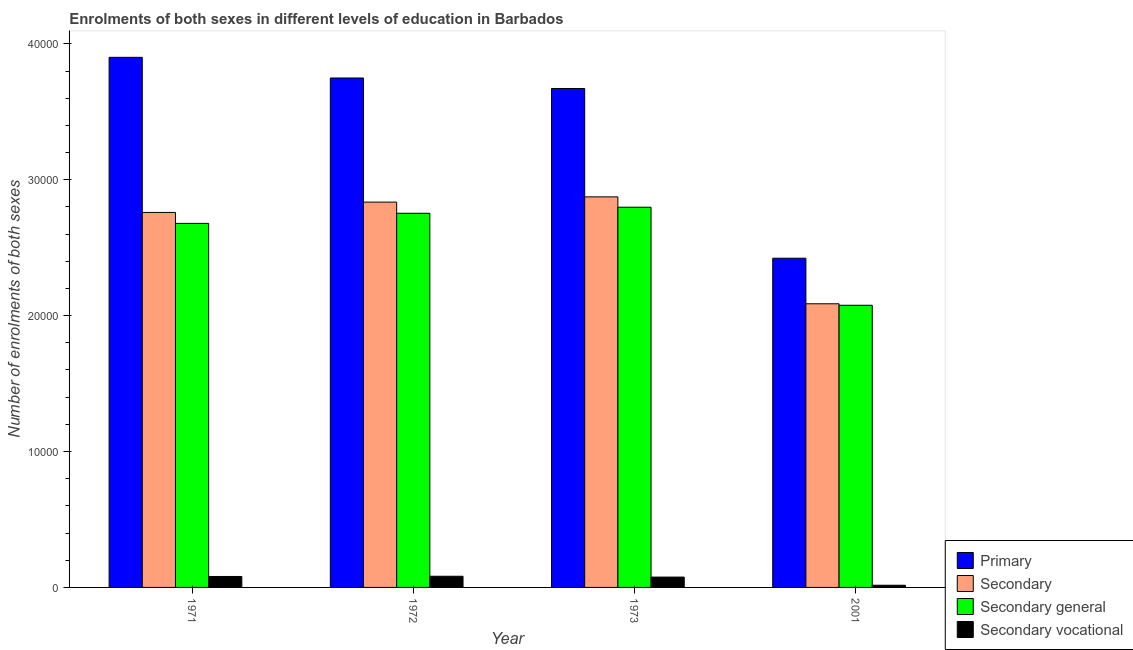How many bars are there on the 4th tick from the right?
Give a very brief answer. 4. What is the label of the 2nd group of bars from the left?
Ensure brevity in your answer.  1972. What is the number of enrolments in secondary education in 1971?
Your response must be concise. 2.76e+04. Across all years, what is the maximum number of enrolments in primary education?
Make the answer very short. 3.90e+04. Across all years, what is the minimum number of enrolments in secondary general education?
Ensure brevity in your answer.  2.08e+04. In which year was the number of enrolments in primary education maximum?
Make the answer very short. 1971. What is the total number of enrolments in primary education in the graph?
Ensure brevity in your answer.  1.37e+05. What is the difference between the number of enrolments in secondary vocational education in 1971 and that in 1972?
Give a very brief answer. -16. What is the difference between the number of enrolments in primary education in 1972 and the number of enrolments in secondary general education in 1973?
Provide a short and direct response. 774. What is the average number of enrolments in secondary general education per year?
Your answer should be very brief. 2.58e+04. In how many years, is the number of enrolments in primary education greater than 36000?
Provide a short and direct response. 3. What is the ratio of the number of enrolments in secondary general education in 1971 to that in 1973?
Your answer should be compact. 0.96. Is the number of enrolments in secondary vocational education in 1973 less than that in 2001?
Make the answer very short. No. What is the difference between the highest and the second highest number of enrolments in primary education?
Provide a short and direct response. 1520. What is the difference between the highest and the lowest number of enrolments in primary education?
Make the answer very short. 1.48e+04. Is the sum of the number of enrolments in secondary education in 1971 and 2001 greater than the maximum number of enrolments in secondary vocational education across all years?
Ensure brevity in your answer.  Yes. What does the 3rd bar from the left in 1973 represents?
Keep it short and to the point. Secondary general. What does the 2nd bar from the right in 1973 represents?
Make the answer very short. Secondary general. Are all the bars in the graph horizontal?
Provide a short and direct response. No. How many years are there in the graph?
Your response must be concise. 4. What is the difference between two consecutive major ticks on the Y-axis?
Provide a succinct answer. 10000. How many legend labels are there?
Your answer should be compact. 4. What is the title of the graph?
Offer a terse response. Enrolments of both sexes in different levels of education in Barbados. Does "Finland" appear as one of the legend labels in the graph?
Keep it short and to the point. No. What is the label or title of the Y-axis?
Your response must be concise. Number of enrolments of both sexes. What is the Number of enrolments of both sexes of Primary in 1971?
Your answer should be very brief. 3.90e+04. What is the Number of enrolments of both sexes of Secondary in 1971?
Give a very brief answer. 2.76e+04. What is the Number of enrolments of both sexes in Secondary general in 1971?
Your response must be concise. 2.68e+04. What is the Number of enrolments of both sexes of Secondary vocational in 1971?
Give a very brief answer. 806. What is the Number of enrolments of both sexes in Primary in 1972?
Offer a very short reply. 3.75e+04. What is the Number of enrolments of both sexes of Secondary in 1972?
Provide a short and direct response. 2.84e+04. What is the Number of enrolments of both sexes in Secondary general in 1972?
Keep it short and to the point. 2.75e+04. What is the Number of enrolments of both sexes in Secondary vocational in 1972?
Your response must be concise. 822. What is the Number of enrolments of both sexes of Primary in 1973?
Ensure brevity in your answer.  3.67e+04. What is the Number of enrolments of both sexes of Secondary in 1973?
Provide a succinct answer. 2.87e+04. What is the Number of enrolments of both sexes in Secondary general in 1973?
Your answer should be compact. 2.80e+04. What is the Number of enrolments of both sexes in Secondary vocational in 1973?
Ensure brevity in your answer.  761. What is the Number of enrolments of both sexes in Primary in 2001?
Your answer should be very brief. 2.42e+04. What is the Number of enrolments of both sexes of Secondary in 2001?
Provide a succinct answer. 2.09e+04. What is the Number of enrolments of both sexes of Secondary general in 2001?
Your answer should be very brief. 2.08e+04. What is the Number of enrolments of both sexes of Secondary vocational in 2001?
Your response must be concise. 161. Across all years, what is the maximum Number of enrolments of both sexes in Primary?
Your answer should be compact. 3.90e+04. Across all years, what is the maximum Number of enrolments of both sexes in Secondary?
Provide a succinct answer. 2.87e+04. Across all years, what is the maximum Number of enrolments of both sexes of Secondary general?
Give a very brief answer. 2.80e+04. Across all years, what is the maximum Number of enrolments of both sexes in Secondary vocational?
Provide a short and direct response. 822. Across all years, what is the minimum Number of enrolments of both sexes in Primary?
Keep it short and to the point. 2.42e+04. Across all years, what is the minimum Number of enrolments of both sexes of Secondary?
Provide a short and direct response. 2.09e+04. Across all years, what is the minimum Number of enrolments of both sexes of Secondary general?
Your response must be concise. 2.08e+04. Across all years, what is the minimum Number of enrolments of both sexes in Secondary vocational?
Your answer should be compact. 161. What is the total Number of enrolments of both sexes in Primary in the graph?
Your answer should be compact. 1.37e+05. What is the total Number of enrolments of both sexes in Secondary in the graph?
Your answer should be compact. 1.06e+05. What is the total Number of enrolments of both sexes in Secondary general in the graph?
Provide a succinct answer. 1.03e+05. What is the total Number of enrolments of both sexes of Secondary vocational in the graph?
Your answer should be compact. 2550. What is the difference between the Number of enrolments of both sexes of Primary in 1971 and that in 1972?
Your answer should be compact. 1520. What is the difference between the Number of enrolments of both sexes of Secondary in 1971 and that in 1972?
Provide a short and direct response. -760. What is the difference between the Number of enrolments of both sexes in Secondary general in 1971 and that in 1972?
Your response must be concise. -744. What is the difference between the Number of enrolments of both sexes of Secondary vocational in 1971 and that in 1972?
Offer a very short reply. -16. What is the difference between the Number of enrolments of both sexes in Primary in 1971 and that in 1973?
Provide a succinct answer. 2294. What is the difference between the Number of enrolments of both sexes in Secondary in 1971 and that in 1973?
Offer a terse response. -1145. What is the difference between the Number of enrolments of both sexes of Secondary general in 1971 and that in 1973?
Your response must be concise. -1190. What is the difference between the Number of enrolments of both sexes of Primary in 1971 and that in 2001?
Offer a terse response. 1.48e+04. What is the difference between the Number of enrolments of both sexes in Secondary in 1971 and that in 2001?
Provide a succinct answer. 6721. What is the difference between the Number of enrolments of both sexes in Secondary general in 1971 and that in 2001?
Your response must be concise. 6025. What is the difference between the Number of enrolments of both sexes of Secondary vocational in 1971 and that in 2001?
Offer a terse response. 645. What is the difference between the Number of enrolments of both sexes in Primary in 1972 and that in 1973?
Offer a terse response. 774. What is the difference between the Number of enrolments of both sexes of Secondary in 1972 and that in 1973?
Make the answer very short. -385. What is the difference between the Number of enrolments of both sexes of Secondary general in 1972 and that in 1973?
Your answer should be compact. -446. What is the difference between the Number of enrolments of both sexes of Primary in 1972 and that in 2001?
Your response must be concise. 1.33e+04. What is the difference between the Number of enrolments of both sexes of Secondary in 1972 and that in 2001?
Your answer should be very brief. 7481. What is the difference between the Number of enrolments of both sexes in Secondary general in 1972 and that in 2001?
Your answer should be very brief. 6769. What is the difference between the Number of enrolments of both sexes in Secondary vocational in 1972 and that in 2001?
Make the answer very short. 661. What is the difference between the Number of enrolments of both sexes of Primary in 1973 and that in 2001?
Provide a succinct answer. 1.25e+04. What is the difference between the Number of enrolments of both sexes of Secondary in 1973 and that in 2001?
Your answer should be compact. 7866. What is the difference between the Number of enrolments of both sexes of Secondary general in 1973 and that in 2001?
Your response must be concise. 7215. What is the difference between the Number of enrolments of both sexes of Secondary vocational in 1973 and that in 2001?
Provide a succinct answer. 600. What is the difference between the Number of enrolments of both sexes of Primary in 1971 and the Number of enrolments of both sexes of Secondary in 1972?
Your response must be concise. 1.07e+04. What is the difference between the Number of enrolments of both sexes in Primary in 1971 and the Number of enrolments of both sexes in Secondary general in 1972?
Offer a very short reply. 1.15e+04. What is the difference between the Number of enrolments of both sexes of Primary in 1971 and the Number of enrolments of both sexes of Secondary vocational in 1972?
Give a very brief answer. 3.82e+04. What is the difference between the Number of enrolments of both sexes in Secondary in 1971 and the Number of enrolments of both sexes in Secondary vocational in 1972?
Keep it short and to the point. 2.68e+04. What is the difference between the Number of enrolments of both sexes in Secondary general in 1971 and the Number of enrolments of both sexes in Secondary vocational in 1972?
Provide a short and direct response. 2.60e+04. What is the difference between the Number of enrolments of both sexes of Primary in 1971 and the Number of enrolments of both sexes of Secondary in 1973?
Your answer should be compact. 1.03e+04. What is the difference between the Number of enrolments of both sexes in Primary in 1971 and the Number of enrolments of both sexes in Secondary general in 1973?
Keep it short and to the point. 1.10e+04. What is the difference between the Number of enrolments of both sexes of Primary in 1971 and the Number of enrolments of both sexes of Secondary vocational in 1973?
Your response must be concise. 3.82e+04. What is the difference between the Number of enrolments of both sexes in Secondary in 1971 and the Number of enrolments of both sexes in Secondary general in 1973?
Give a very brief answer. -384. What is the difference between the Number of enrolments of both sexes of Secondary in 1971 and the Number of enrolments of both sexes of Secondary vocational in 1973?
Your answer should be compact. 2.68e+04. What is the difference between the Number of enrolments of both sexes in Secondary general in 1971 and the Number of enrolments of both sexes in Secondary vocational in 1973?
Give a very brief answer. 2.60e+04. What is the difference between the Number of enrolments of both sexes in Primary in 1971 and the Number of enrolments of both sexes in Secondary in 2001?
Your answer should be very brief. 1.81e+04. What is the difference between the Number of enrolments of both sexes of Primary in 1971 and the Number of enrolments of both sexes of Secondary general in 2001?
Make the answer very short. 1.82e+04. What is the difference between the Number of enrolments of both sexes in Primary in 1971 and the Number of enrolments of both sexes in Secondary vocational in 2001?
Offer a terse response. 3.88e+04. What is the difference between the Number of enrolments of both sexes in Secondary in 1971 and the Number of enrolments of both sexes in Secondary general in 2001?
Your response must be concise. 6831. What is the difference between the Number of enrolments of both sexes of Secondary in 1971 and the Number of enrolments of both sexes of Secondary vocational in 2001?
Ensure brevity in your answer.  2.74e+04. What is the difference between the Number of enrolments of both sexes of Secondary general in 1971 and the Number of enrolments of both sexes of Secondary vocational in 2001?
Ensure brevity in your answer.  2.66e+04. What is the difference between the Number of enrolments of both sexes of Primary in 1972 and the Number of enrolments of both sexes of Secondary in 1973?
Offer a terse response. 8748. What is the difference between the Number of enrolments of both sexes of Primary in 1972 and the Number of enrolments of both sexes of Secondary general in 1973?
Ensure brevity in your answer.  9509. What is the difference between the Number of enrolments of both sexes of Primary in 1972 and the Number of enrolments of both sexes of Secondary vocational in 1973?
Your answer should be very brief. 3.67e+04. What is the difference between the Number of enrolments of both sexes of Secondary in 1972 and the Number of enrolments of both sexes of Secondary general in 1973?
Provide a short and direct response. 376. What is the difference between the Number of enrolments of both sexes of Secondary in 1972 and the Number of enrolments of both sexes of Secondary vocational in 1973?
Make the answer very short. 2.76e+04. What is the difference between the Number of enrolments of both sexes in Secondary general in 1972 and the Number of enrolments of both sexes in Secondary vocational in 1973?
Give a very brief answer. 2.68e+04. What is the difference between the Number of enrolments of both sexes of Primary in 1972 and the Number of enrolments of both sexes of Secondary in 2001?
Your response must be concise. 1.66e+04. What is the difference between the Number of enrolments of both sexes of Primary in 1972 and the Number of enrolments of both sexes of Secondary general in 2001?
Offer a terse response. 1.67e+04. What is the difference between the Number of enrolments of both sexes in Primary in 1972 and the Number of enrolments of both sexes in Secondary vocational in 2001?
Give a very brief answer. 3.73e+04. What is the difference between the Number of enrolments of both sexes of Secondary in 1972 and the Number of enrolments of both sexes of Secondary general in 2001?
Your answer should be very brief. 7591. What is the difference between the Number of enrolments of both sexes of Secondary in 1972 and the Number of enrolments of both sexes of Secondary vocational in 2001?
Make the answer very short. 2.82e+04. What is the difference between the Number of enrolments of both sexes of Secondary general in 1972 and the Number of enrolments of both sexes of Secondary vocational in 2001?
Your answer should be very brief. 2.74e+04. What is the difference between the Number of enrolments of both sexes of Primary in 1973 and the Number of enrolments of both sexes of Secondary in 2001?
Offer a very short reply. 1.58e+04. What is the difference between the Number of enrolments of both sexes in Primary in 1973 and the Number of enrolments of both sexes in Secondary general in 2001?
Provide a succinct answer. 1.60e+04. What is the difference between the Number of enrolments of both sexes of Primary in 1973 and the Number of enrolments of both sexes of Secondary vocational in 2001?
Offer a terse response. 3.66e+04. What is the difference between the Number of enrolments of both sexes in Secondary in 1973 and the Number of enrolments of both sexes in Secondary general in 2001?
Your response must be concise. 7976. What is the difference between the Number of enrolments of both sexes of Secondary in 1973 and the Number of enrolments of both sexes of Secondary vocational in 2001?
Keep it short and to the point. 2.86e+04. What is the difference between the Number of enrolments of both sexes of Secondary general in 1973 and the Number of enrolments of both sexes of Secondary vocational in 2001?
Ensure brevity in your answer.  2.78e+04. What is the average Number of enrolments of both sexes in Primary per year?
Offer a very short reply. 3.44e+04. What is the average Number of enrolments of both sexes of Secondary per year?
Offer a very short reply. 2.64e+04. What is the average Number of enrolments of both sexes in Secondary general per year?
Give a very brief answer. 2.58e+04. What is the average Number of enrolments of both sexes of Secondary vocational per year?
Your answer should be compact. 637.5. In the year 1971, what is the difference between the Number of enrolments of both sexes in Primary and Number of enrolments of both sexes in Secondary?
Offer a very short reply. 1.14e+04. In the year 1971, what is the difference between the Number of enrolments of both sexes of Primary and Number of enrolments of both sexes of Secondary general?
Provide a short and direct response. 1.22e+04. In the year 1971, what is the difference between the Number of enrolments of both sexes in Primary and Number of enrolments of both sexes in Secondary vocational?
Give a very brief answer. 3.82e+04. In the year 1971, what is the difference between the Number of enrolments of both sexes of Secondary and Number of enrolments of both sexes of Secondary general?
Offer a terse response. 806. In the year 1971, what is the difference between the Number of enrolments of both sexes of Secondary and Number of enrolments of both sexes of Secondary vocational?
Provide a succinct answer. 2.68e+04. In the year 1971, what is the difference between the Number of enrolments of both sexes in Secondary general and Number of enrolments of both sexes in Secondary vocational?
Your answer should be compact. 2.60e+04. In the year 1972, what is the difference between the Number of enrolments of both sexes of Primary and Number of enrolments of both sexes of Secondary?
Make the answer very short. 9133. In the year 1972, what is the difference between the Number of enrolments of both sexes in Primary and Number of enrolments of both sexes in Secondary general?
Your answer should be compact. 9955. In the year 1972, what is the difference between the Number of enrolments of both sexes in Primary and Number of enrolments of both sexes in Secondary vocational?
Provide a short and direct response. 3.67e+04. In the year 1972, what is the difference between the Number of enrolments of both sexes of Secondary and Number of enrolments of both sexes of Secondary general?
Give a very brief answer. 822. In the year 1972, what is the difference between the Number of enrolments of both sexes in Secondary and Number of enrolments of both sexes in Secondary vocational?
Ensure brevity in your answer.  2.75e+04. In the year 1972, what is the difference between the Number of enrolments of both sexes in Secondary general and Number of enrolments of both sexes in Secondary vocational?
Offer a very short reply. 2.67e+04. In the year 1973, what is the difference between the Number of enrolments of both sexes in Primary and Number of enrolments of both sexes in Secondary?
Provide a short and direct response. 7974. In the year 1973, what is the difference between the Number of enrolments of both sexes in Primary and Number of enrolments of both sexes in Secondary general?
Provide a succinct answer. 8735. In the year 1973, what is the difference between the Number of enrolments of both sexes in Primary and Number of enrolments of both sexes in Secondary vocational?
Your response must be concise. 3.60e+04. In the year 1973, what is the difference between the Number of enrolments of both sexes in Secondary and Number of enrolments of both sexes in Secondary general?
Offer a terse response. 761. In the year 1973, what is the difference between the Number of enrolments of both sexes of Secondary and Number of enrolments of both sexes of Secondary vocational?
Provide a short and direct response. 2.80e+04. In the year 1973, what is the difference between the Number of enrolments of both sexes of Secondary general and Number of enrolments of both sexes of Secondary vocational?
Make the answer very short. 2.72e+04. In the year 2001, what is the difference between the Number of enrolments of both sexes in Primary and Number of enrolments of both sexes in Secondary?
Provide a short and direct response. 3353. In the year 2001, what is the difference between the Number of enrolments of both sexes of Primary and Number of enrolments of both sexes of Secondary general?
Offer a terse response. 3463. In the year 2001, what is the difference between the Number of enrolments of both sexes of Primary and Number of enrolments of both sexes of Secondary vocational?
Ensure brevity in your answer.  2.41e+04. In the year 2001, what is the difference between the Number of enrolments of both sexes in Secondary and Number of enrolments of both sexes in Secondary general?
Your answer should be very brief. 110. In the year 2001, what is the difference between the Number of enrolments of both sexes of Secondary and Number of enrolments of both sexes of Secondary vocational?
Your response must be concise. 2.07e+04. In the year 2001, what is the difference between the Number of enrolments of both sexes in Secondary general and Number of enrolments of both sexes in Secondary vocational?
Offer a terse response. 2.06e+04. What is the ratio of the Number of enrolments of both sexes of Primary in 1971 to that in 1972?
Your answer should be very brief. 1.04. What is the ratio of the Number of enrolments of both sexes in Secondary in 1971 to that in 1972?
Ensure brevity in your answer.  0.97. What is the ratio of the Number of enrolments of both sexes in Secondary general in 1971 to that in 1972?
Give a very brief answer. 0.97. What is the ratio of the Number of enrolments of both sexes in Secondary vocational in 1971 to that in 1972?
Offer a very short reply. 0.98. What is the ratio of the Number of enrolments of both sexes of Secondary in 1971 to that in 1973?
Your answer should be very brief. 0.96. What is the ratio of the Number of enrolments of both sexes of Secondary general in 1971 to that in 1973?
Keep it short and to the point. 0.96. What is the ratio of the Number of enrolments of both sexes in Secondary vocational in 1971 to that in 1973?
Keep it short and to the point. 1.06. What is the ratio of the Number of enrolments of both sexes in Primary in 1971 to that in 2001?
Your response must be concise. 1.61. What is the ratio of the Number of enrolments of both sexes of Secondary in 1971 to that in 2001?
Provide a succinct answer. 1.32. What is the ratio of the Number of enrolments of both sexes in Secondary general in 1971 to that in 2001?
Your answer should be very brief. 1.29. What is the ratio of the Number of enrolments of both sexes in Secondary vocational in 1971 to that in 2001?
Your answer should be compact. 5.01. What is the ratio of the Number of enrolments of both sexes of Primary in 1972 to that in 1973?
Keep it short and to the point. 1.02. What is the ratio of the Number of enrolments of both sexes of Secondary in 1972 to that in 1973?
Keep it short and to the point. 0.99. What is the ratio of the Number of enrolments of both sexes of Secondary general in 1972 to that in 1973?
Your answer should be compact. 0.98. What is the ratio of the Number of enrolments of both sexes of Secondary vocational in 1972 to that in 1973?
Give a very brief answer. 1.08. What is the ratio of the Number of enrolments of both sexes in Primary in 1972 to that in 2001?
Offer a terse response. 1.55. What is the ratio of the Number of enrolments of both sexes of Secondary in 1972 to that in 2001?
Provide a succinct answer. 1.36. What is the ratio of the Number of enrolments of both sexes in Secondary general in 1972 to that in 2001?
Your response must be concise. 1.33. What is the ratio of the Number of enrolments of both sexes of Secondary vocational in 1972 to that in 2001?
Offer a very short reply. 5.11. What is the ratio of the Number of enrolments of both sexes of Primary in 1973 to that in 2001?
Make the answer very short. 1.52. What is the ratio of the Number of enrolments of both sexes of Secondary in 1973 to that in 2001?
Offer a very short reply. 1.38. What is the ratio of the Number of enrolments of both sexes of Secondary general in 1973 to that in 2001?
Offer a very short reply. 1.35. What is the ratio of the Number of enrolments of both sexes of Secondary vocational in 1973 to that in 2001?
Your answer should be very brief. 4.73. What is the difference between the highest and the second highest Number of enrolments of both sexes of Primary?
Keep it short and to the point. 1520. What is the difference between the highest and the second highest Number of enrolments of both sexes of Secondary?
Ensure brevity in your answer.  385. What is the difference between the highest and the second highest Number of enrolments of both sexes of Secondary general?
Keep it short and to the point. 446. What is the difference between the highest and the lowest Number of enrolments of both sexes in Primary?
Offer a very short reply. 1.48e+04. What is the difference between the highest and the lowest Number of enrolments of both sexes of Secondary?
Your answer should be compact. 7866. What is the difference between the highest and the lowest Number of enrolments of both sexes of Secondary general?
Provide a short and direct response. 7215. What is the difference between the highest and the lowest Number of enrolments of both sexes of Secondary vocational?
Your response must be concise. 661. 